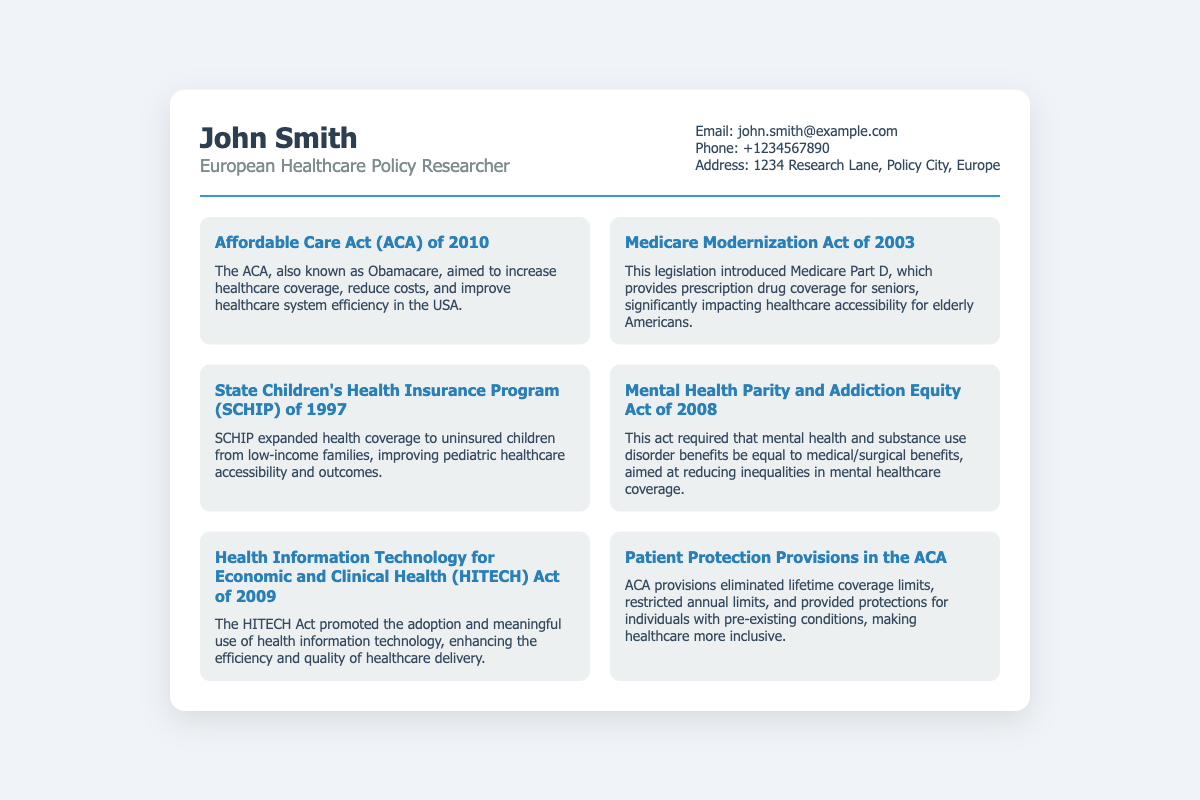What is the name of the researcher? The name of the researcher is mentioned at the top of the business card.
Answer: John Smith What is the profession of John Smith? The profession is listed under his name on the business card.
Answer: European Healthcare Policy Researcher What is the email address provided? The email address is displayed in the contact info section of the business card.
Answer: john.smith@example.com What legislation was introduced by the Medicare Modernization Act? The description specifies what the act introduced regarding drug coverage.
Answer: Medicare Part D In what year was the Affordable Care Act enacted? The document clearly states the year associated with the ACA achievement.
Answer: 2010 How many healthcare achievements are listed on the business card? By counting the achievements section, we determine the total amount.
Answer: Six What act requires mental health benefits to be equal to medical benefits? The specific act addressing mental health parity is indicated.
Answer: Mental Health Parity and Addiction Equity Act What does HITECH stand for? The acronym is presented in the context of the legislation mentioned in the document.
Answer: Health Information Technology for Economic and Clinical Health What benefit did SCHIP expand? The achievement describes the target group affected by SCHIP.
Answer: Health coverage for uninsured children 